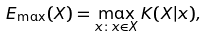Convert formula to latex. <formula><loc_0><loc_0><loc_500><loc_500>E _ { \max } ( X ) = \max _ { x \colon x \in X } K ( X | x ) ,</formula> 